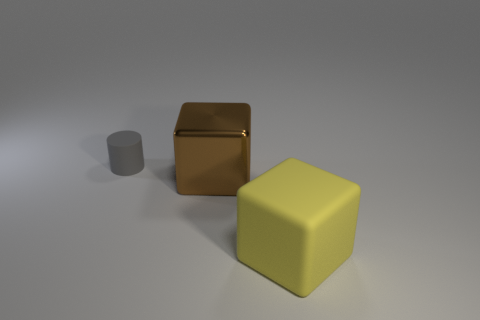There is a yellow object that is the same size as the metal cube; what is its shape?
Your response must be concise. Cube. Are there the same number of tiny cylinders that are to the right of the brown thing and big brown metallic blocks that are behind the rubber cylinder?
Offer a very short reply. Yes. Is the shape of the big yellow matte object the same as the rubber thing left of the big matte cube?
Make the answer very short. No. What number of other objects are there of the same material as the small gray object?
Provide a short and direct response. 1. There is a large brown metallic block; are there any things on the left side of it?
Your response must be concise. Yes. Does the brown thing have the same size as the rubber object that is in front of the small object?
Offer a terse response. Yes. There is a large thing that is behind the big object that is right of the metallic block; what is its color?
Make the answer very short. Brown. Do the yellow cube and the gray cylinder have the same size?
Your response must be concise. No. There is a thing that is both behind the yellow thing and in front of the small gray matte cylinder; what is its color?
Provide a succinct answer. Brown. What is the size of the gray rubber cylinder?
Offer a very short reply. Small. 